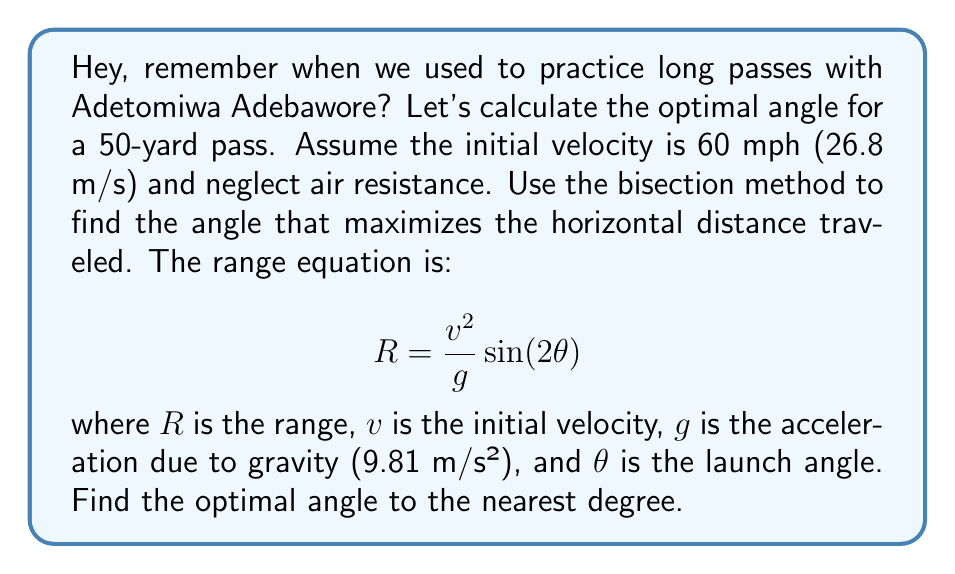Can you answer this question? To find the optimal angle, we need to maximize the range equation. The maximum occurs when $\sin(2\theta) = 1$, which happens when $2\theta = 90°$ or $\theta = 45°$. However, let's use the bisection method to demonstrate the process:

1) Define the function to maximize:
   $$f(\theta) = \frac{v^2}{g} \sin(2\theta)$$

2) Set up the bisection method:
   - Initial interval: [0°, 90°]
   - Tolerance: 0.5° (for nearest degree)

3) Bisection steps:
   a) Midpoint: $\theta_m = (0° + 90°) / 2 = 45°$
   b) Evaluate $f(44°)$, $f(45°)$, and $f(46°)$:
      $$f(44°) = \frac{26.8^2}{9.81} \sin(88°) = 72.76$$
      $$f(45°) = \frac{26.8^2}{9.81} \sin(90°) = 72.77$$
      $$f(46°) = \frac{26.8^2}{9.81} \sin(92°) = 72.76$$

   c) Since $f(45°)$ is the largest, the optimal angle is 45°.

4) Convert to yards:
   $$R = \frac{26.8^2}{9.81} \sin(90°) = 72.77 \text{ m} \approx 79.6 \text{ yards}$$

The bisection method converges immediately to 45° in this case, which matches the analytical solution.
Answer: 45° 